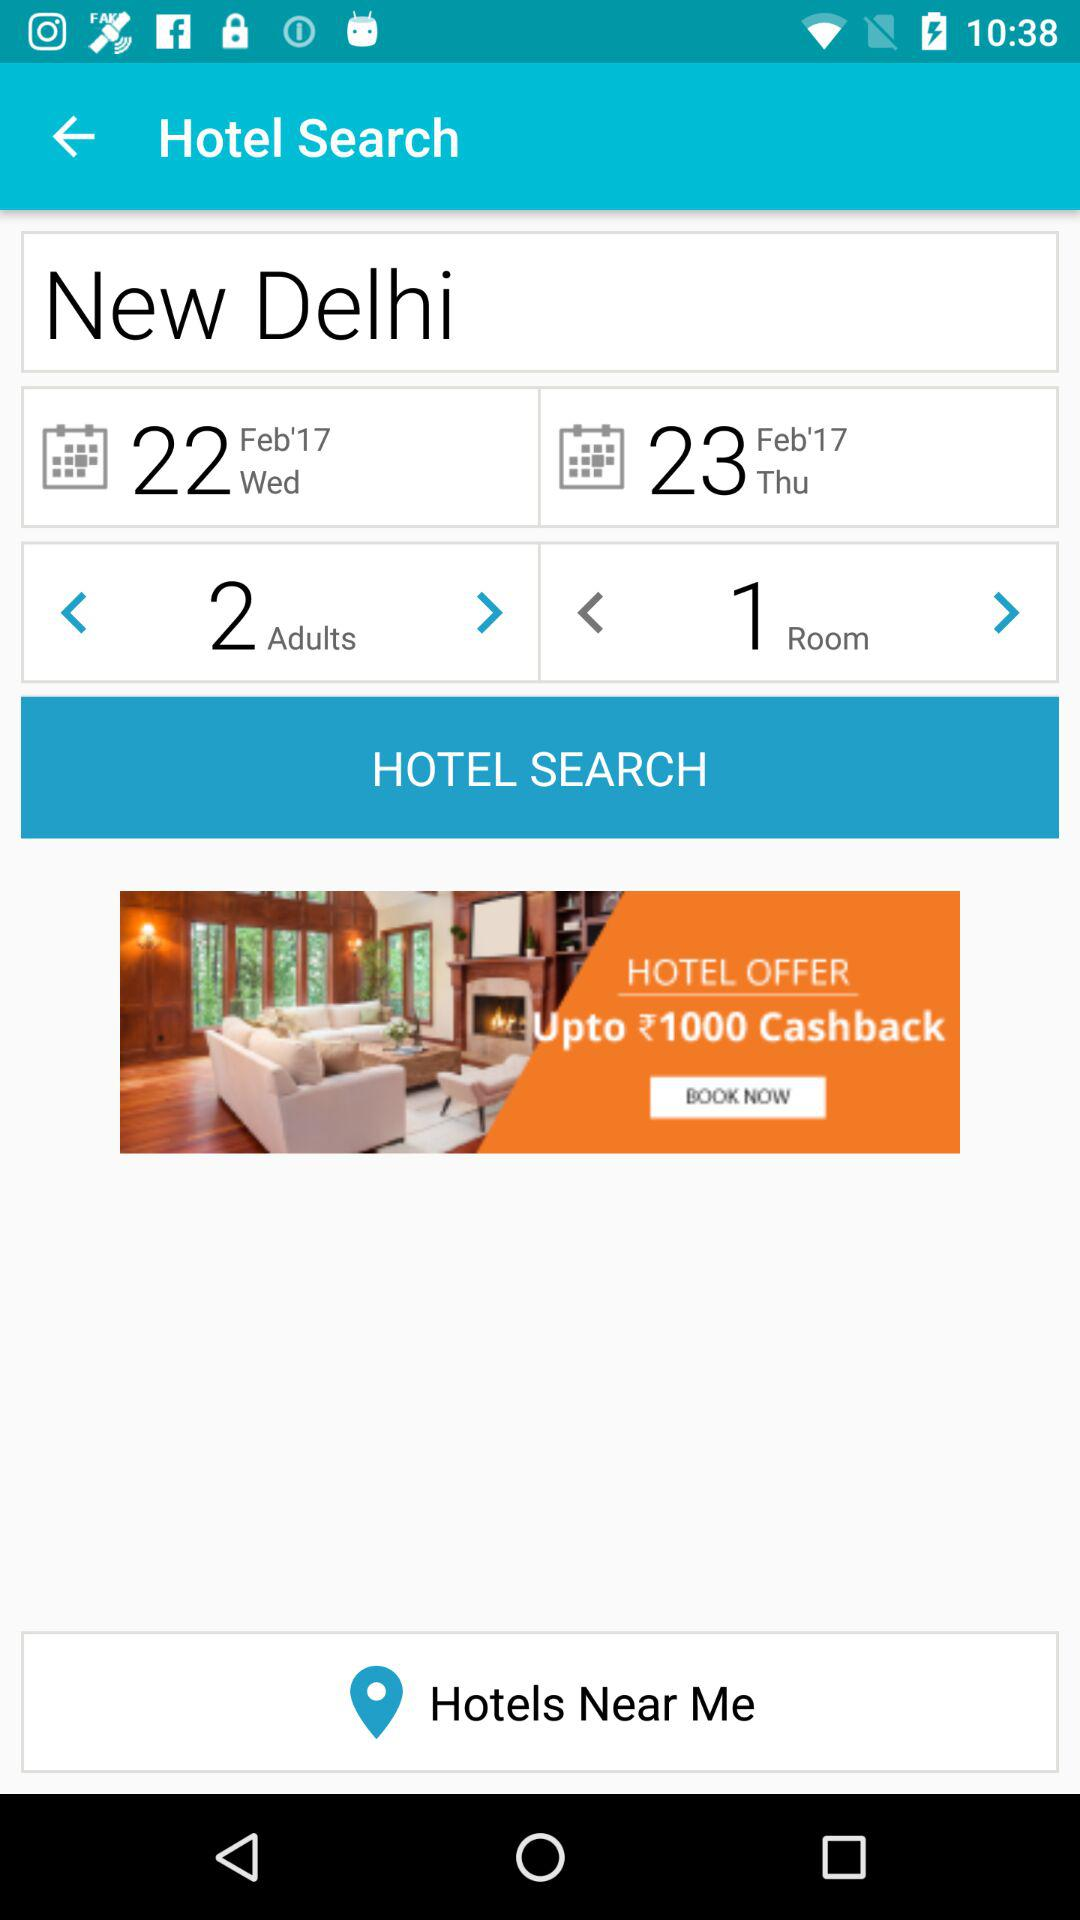What is the given year? The given year is 2017. 